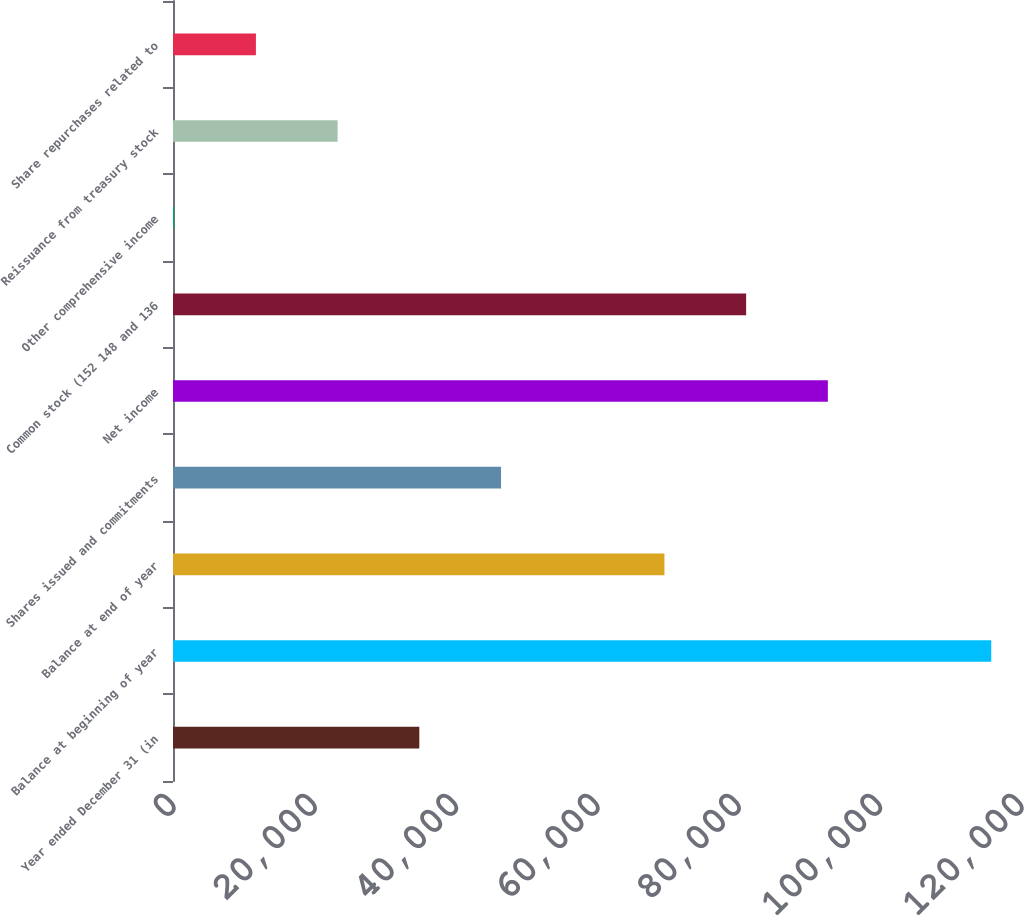Convert chart to OTSL. <chart><loc_0><loc_0><loc_500><loc_500><bar_chart><fcel>Year ended December 31 (in<fcel>Balance at beginning of year<fcel>Balance at end of year<fcel>Shares issued and commitments<fcel>Net income<fcel>Common stock (152 148 and 136<fcel>Other comprehensive income<fcel>Reissuance from treasury stock<fcel>Share repurchases related to<nl><fcel>34856.7<fcel>115790<fcel>69542.4<fcel>46418.6<fcel>92666.2<fcel>81104.3<fcel>171<fcel>23294.8<fcel>11732.9<nl></chart> 